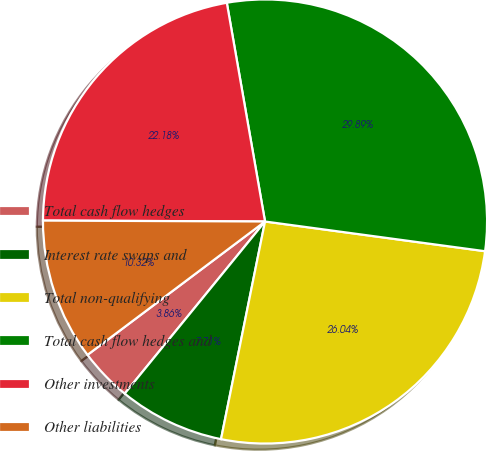<chart> <loc_0><loc_0><loc_500><loc_500><pie_chart><fcel>Total cash flow hedges<fcel>Interest rate swaps and<fcel>Total non-qualifying<fcel>Total cash flow hedges and<fcel>Other investments<fcel>Other liabilities<nl><fcel>3.86%<fcel>7.71%<fcel>26.04%<fcel>29.89%<fcel>22.18%<fcel>10.32%<nl></chart> 